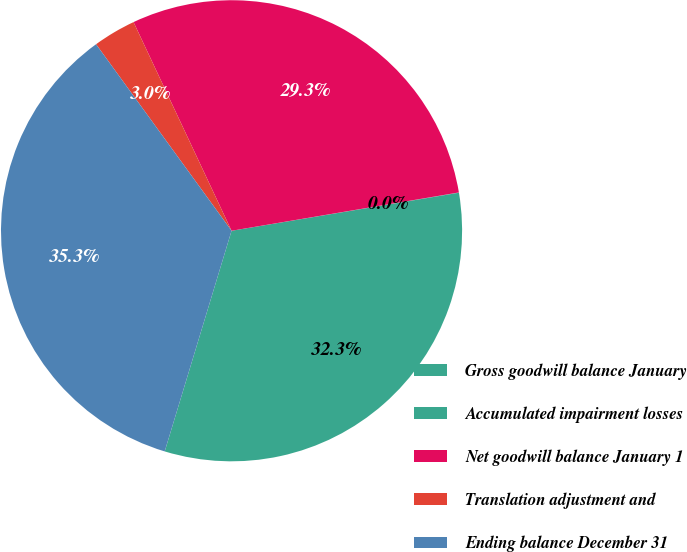<chart> <loc_0><loc_0><loc_500><loc_500><pie_chart><fcel>Gross goodwill balance January<fcel>Accumulated impairment losses<fcel>Net goodwill balance January 1<fcel>Translation adjustment and<fcel>Ending balance December 31<nl><fcel>32.32%<fcel>0.02%<fcel>29.33%<fcel>3.01%<fcel>35.32%<nl></chart> 